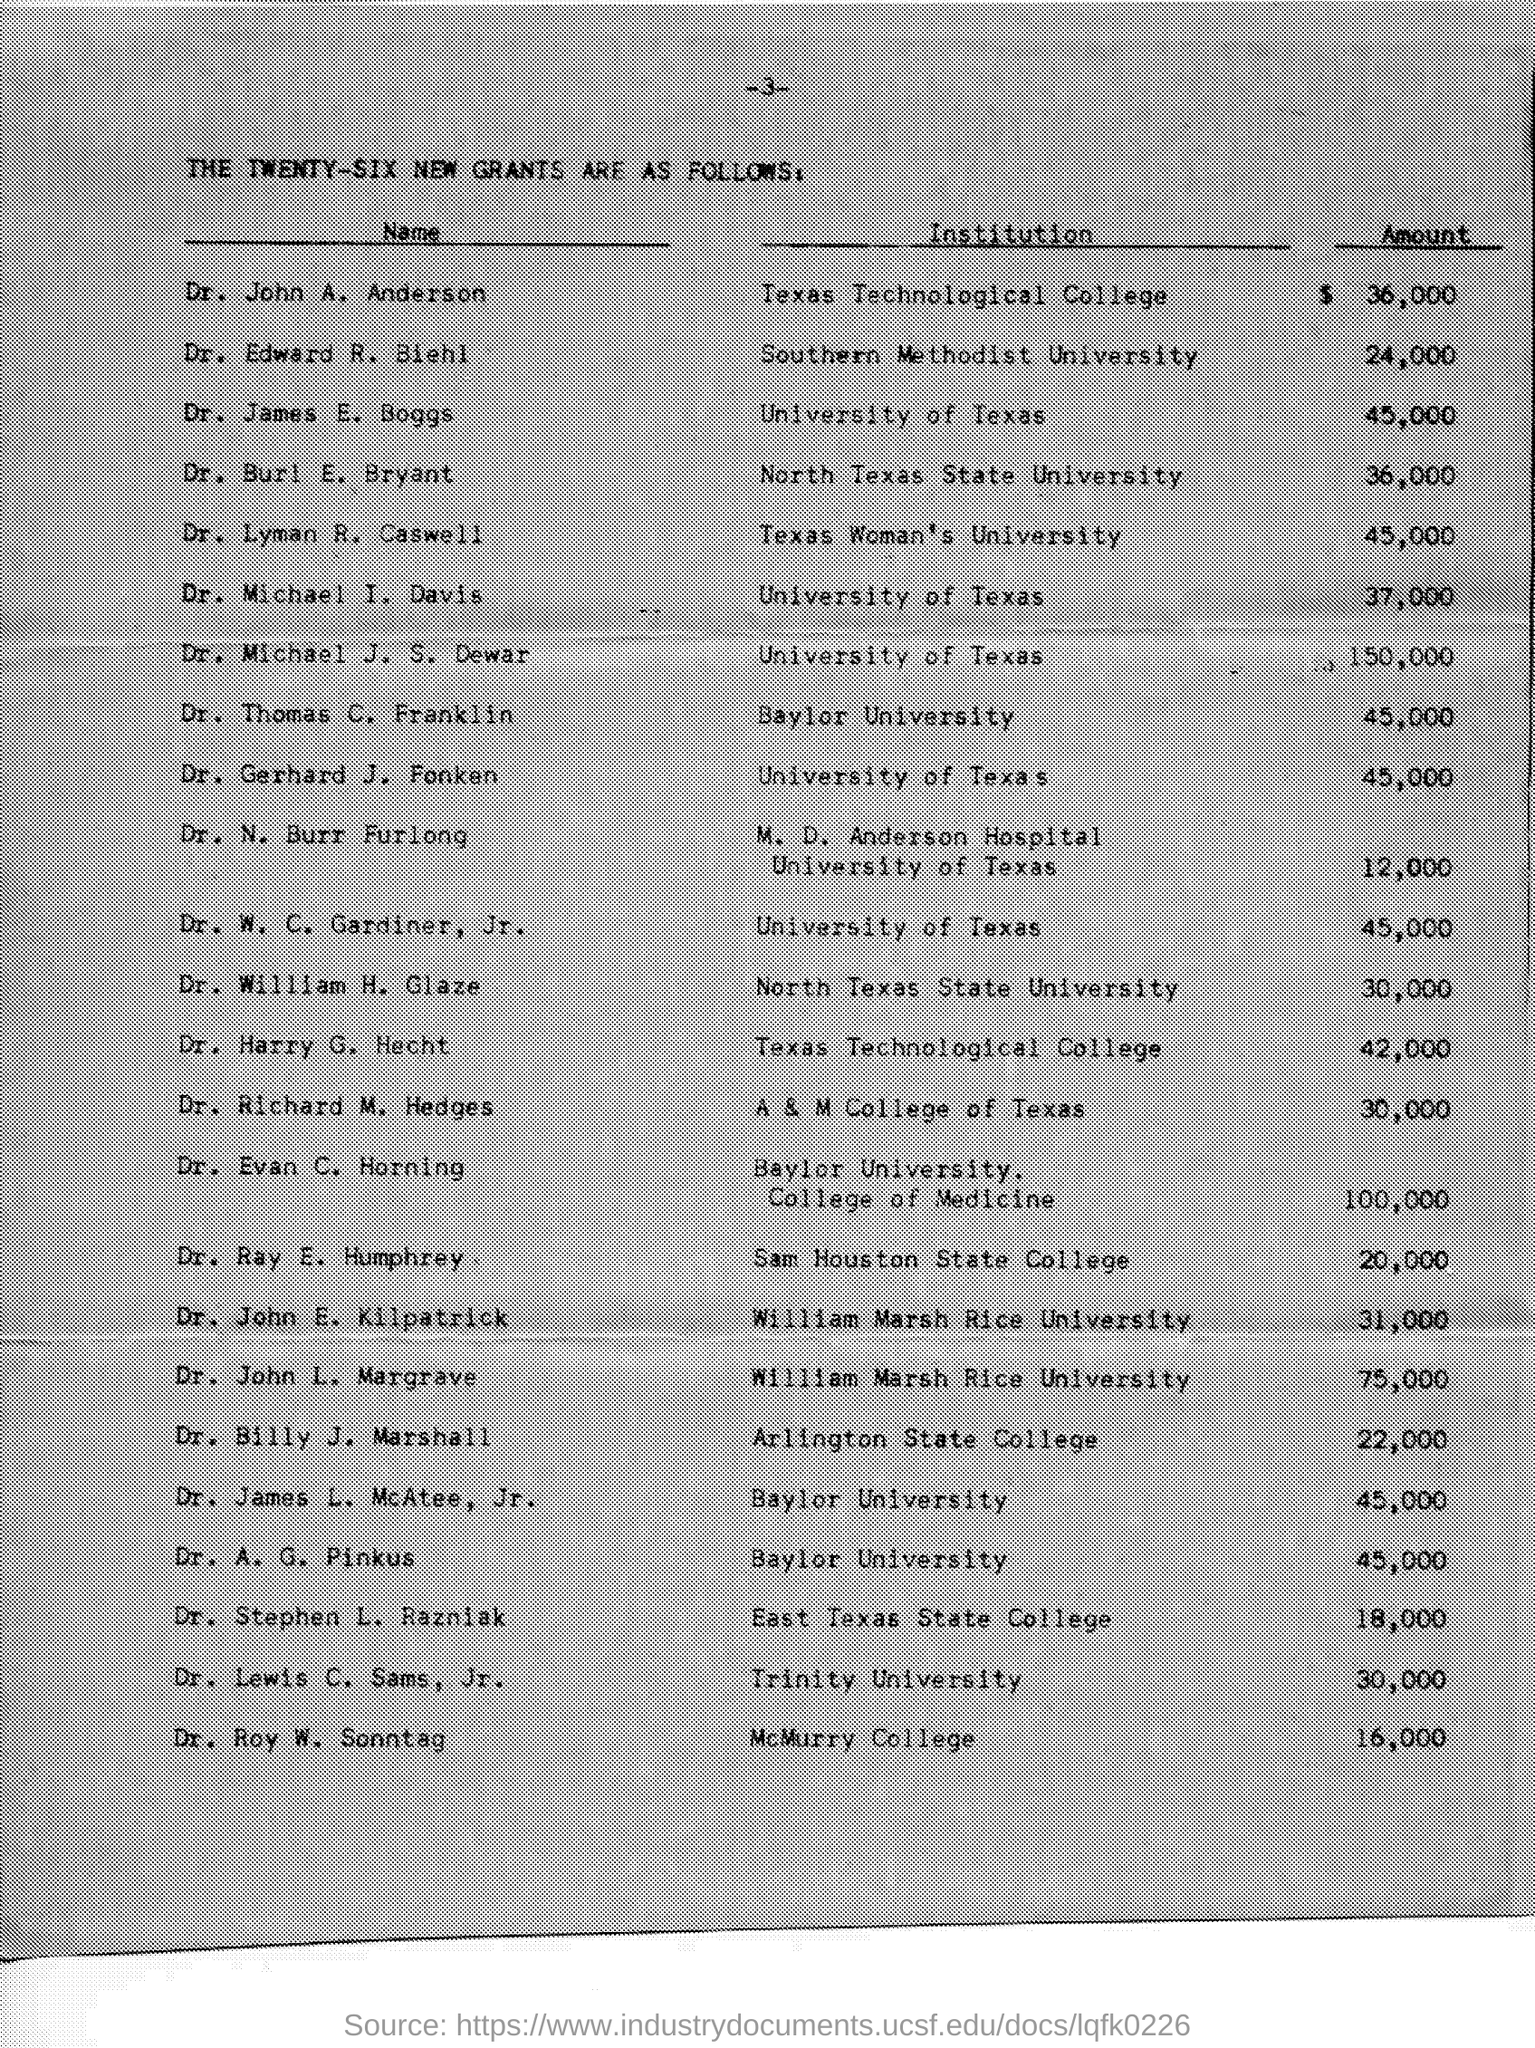What is the Institution for Dr. John A. Anderson?
Ensure brevity in your answer.  Texas Technological college. What is the Institution for Dr. Edward R. Biehl?
Provide a short and direct response. Southern Methodist University. What is the Institution for Dr. James E. Boggs?
Your response must be concise. University of Texas. What is the Institution for Dr. Lyman R. Caswell?
Provide a short and direct response. Texas Woman's University. What is the Institution for Dr. Michael I. Davis?
Give a very brief answer. University of Texas. What is the Institution for Dr. Michael J. S. Dewar?
Your answer should be compact. University of Texas. What is the Institution for Dr. Thomas C. Franklin?
Offer a very short reply. Baylor University. What is the Institution for Dr. A. G. Pinkus?
Provide a succinct answer. Baylor University. 